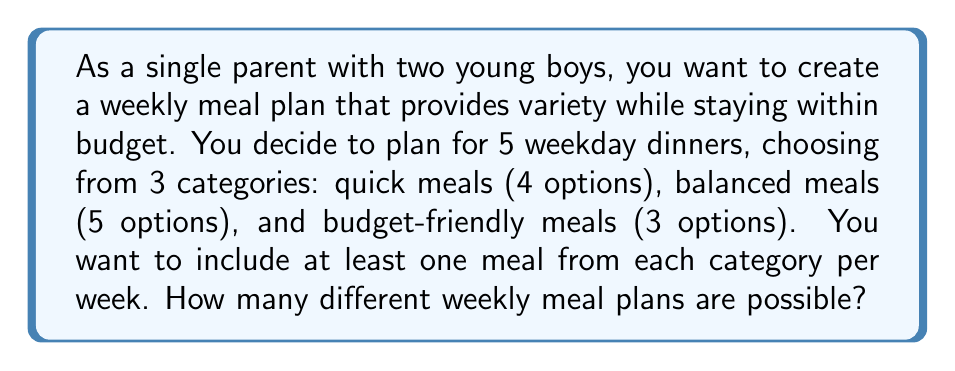Provide a solution to this math problem. Let's approach this step-by-step using the concept of combinations and the multiplication principle:

1) We need to choose 5 meals in total, with at least one from each category.

2) To ensure we have at least one from each category, let's first select one meal from each:
   - 1 from quick meals: $\binom{4}{1} = 4$ ways
   - 1 from balanced meals: $\binom{5}{1} = 5$ ways
   - 1 from budget-friendly meals: $\binom{3}{1} = 3$ ways

3) Now we have 2 more meals to choose, which can come from any category. We have 12 options in total (4 + 5 + 3).

4) Choosing 2 meals from 12 options: $\binom{12}{2} = 66$ ways

5) By the multiplication principle, the total number of ways to create the meal plan is:

   $$4 \times 5 \times 3 \times 66 = 3,960$$

However, this counts each specific combination of 5 meals multiple times, because the order in which we chose them doesn't matter for a weekly plan.

6) To correct for this overcounting, we need to divide by the number of ways to arrange 5 meals, which is 5! = 120.

7) Therefore, the final number of possible meal plans is:

   $$\frac{3,960}{120} = 33$$
Answer: 33 different weekly meal plans are possible. 